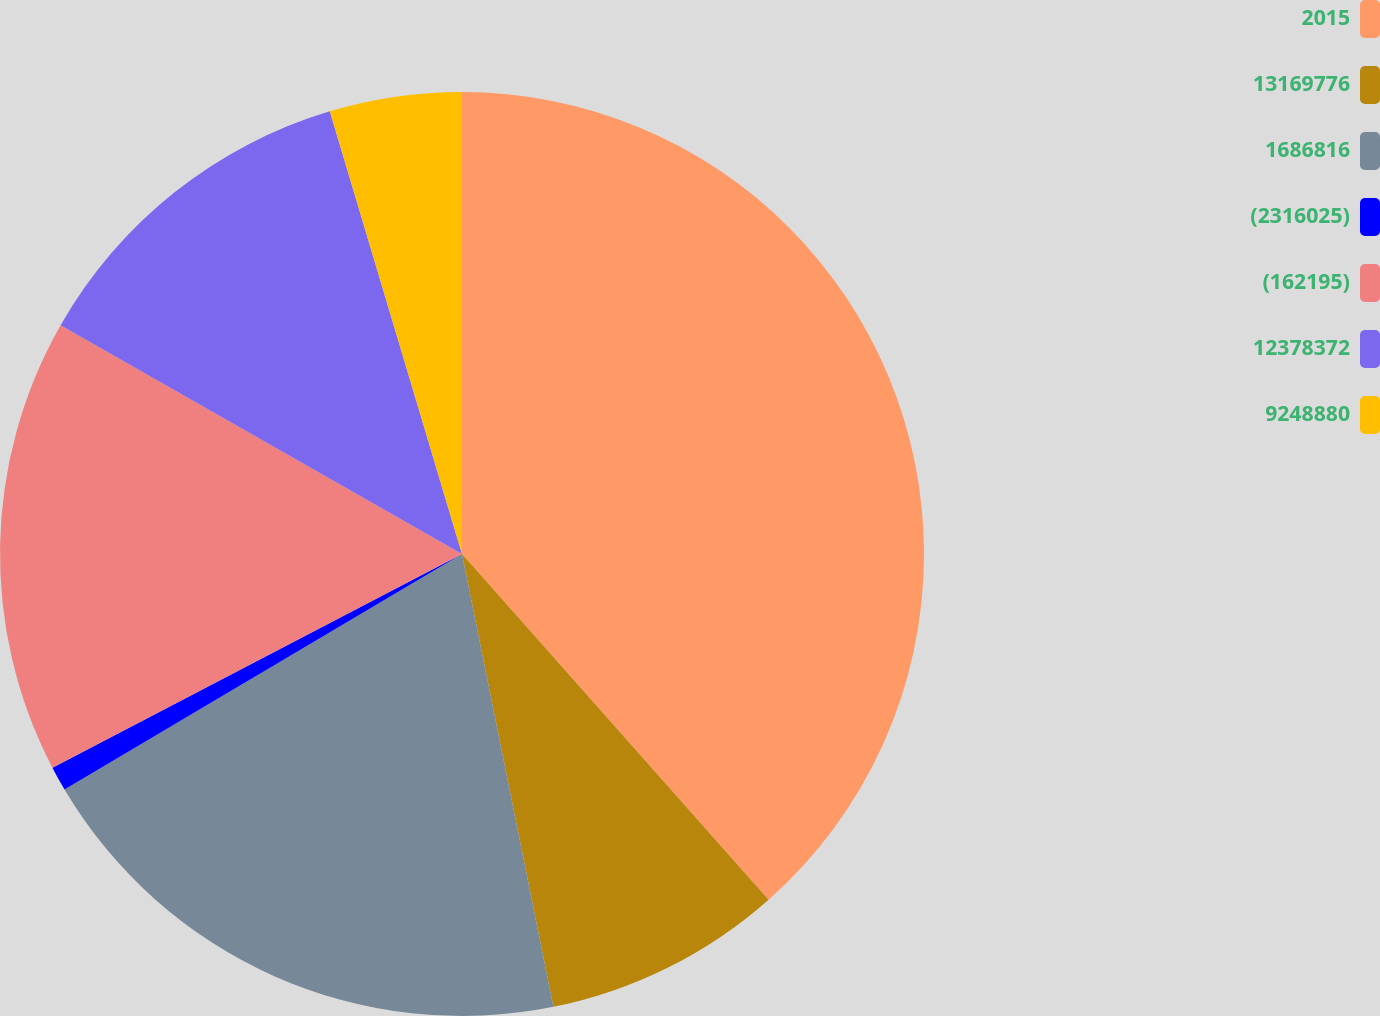Convert chart to OTSL. <chart><loc_0><loc_0><loc_500><loc_500><pie_chart><fcel>2015<fcel>13169776<fcel>1686816<fcel>(2316025)<fcel>(162195)<fcel>12378372<fcel>9248880<nl><fcel>38.46%<fcel>8.38%<fcel>19.66%<fcel>0.86%<fcel>15.9%<fcel>12.14%<fcel>4.62%<nl></chart> 